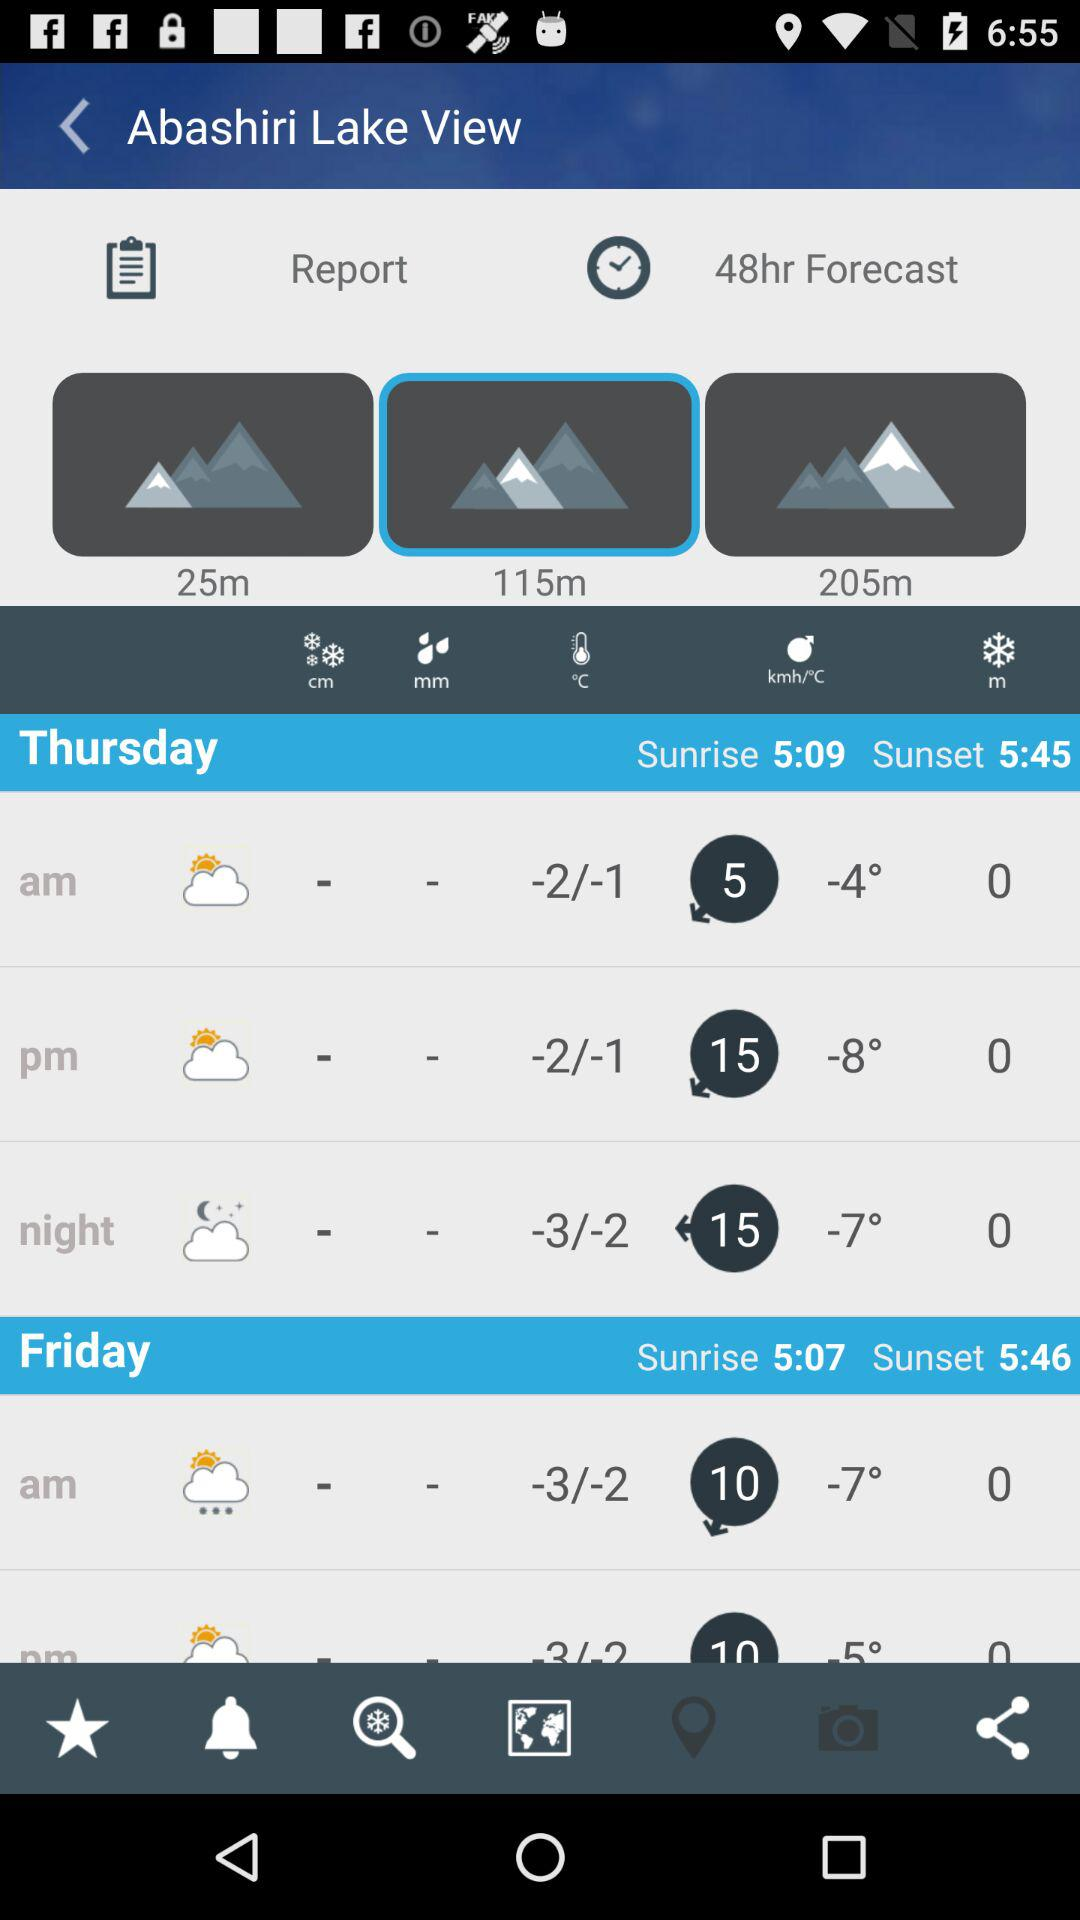What is the given location? The given location is Abashiri. 